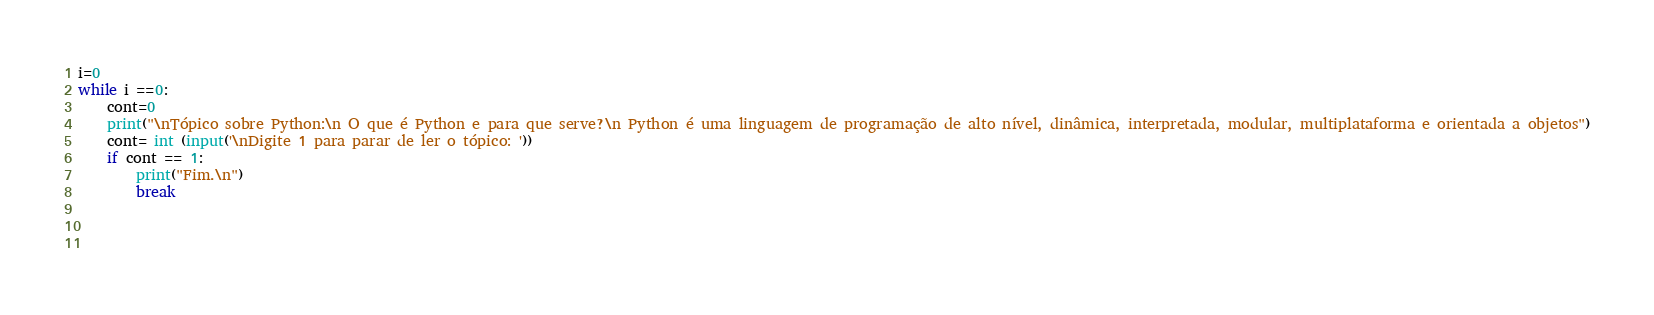<code> <loc_0><loc_0><loc_500><loc_500><_Python_>i=0
while i ==0:
    cont=0
    print("\nTópico sobre Python:\n O que é Python e para que serve?\n Python é uma linguagem de programação de alto nível, dinâmica, interpretada, modular, multiplataforma e orientada a objetos")
    cont= int (input('\nDigite 1 para parar de ler o tópico: '))
    if cont == 1:
        print("Fim.\n")
        break
    
   
    
</code> 